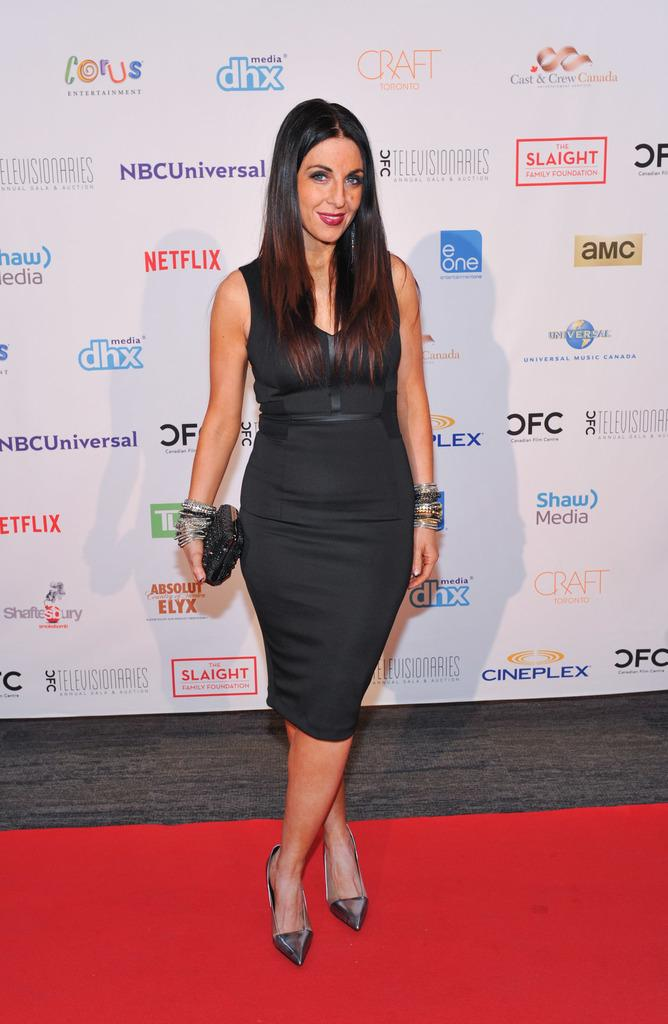Who is present in the image? There is a woman in the image. What is the woman doing with her hand? The woman is holding an object with her hand. What is the woman standing on? The woman is standing on a red carpet. What is the woman's facial expression? The woman is smiling. What can be seen in the background of the image? There is a banner in the background of the image. What type of expansion is the woman promoting in the image? There is no indication of any expansion being promoted in the image. 